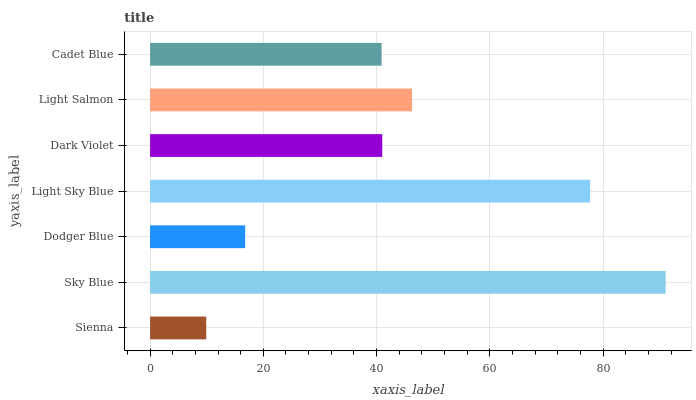Is Sienna the minimum?
Answer yes or no. Yes. Is Sky Blue the maximum?
Answer yes or no. Yes. Is Dodger Blue the minimum?
Answer yes or no. No. Is Dodger Blue the maximum?
Answer yes or no. No. Is Sky Blue greater than Dodger Blue?
Answer yes or no. Yes. Is Dodger Blue less than Sky Blue?
Answer yes or no. Yes. Is Dodger Blue greater than Sky Blue?
Answer yes or no. No. Is Sky Blue less than Dodger Blue?
Answer yes or no. No. Is Dark Violet the high median?
Answer yes or no. Yes. Is Dark Violet the low median?
Answer yes or no. Yes. Is Cadet Blue the high median?
Answer yes or no. No. Is Cadet Blue the low median?
Answer yes or no. No. 